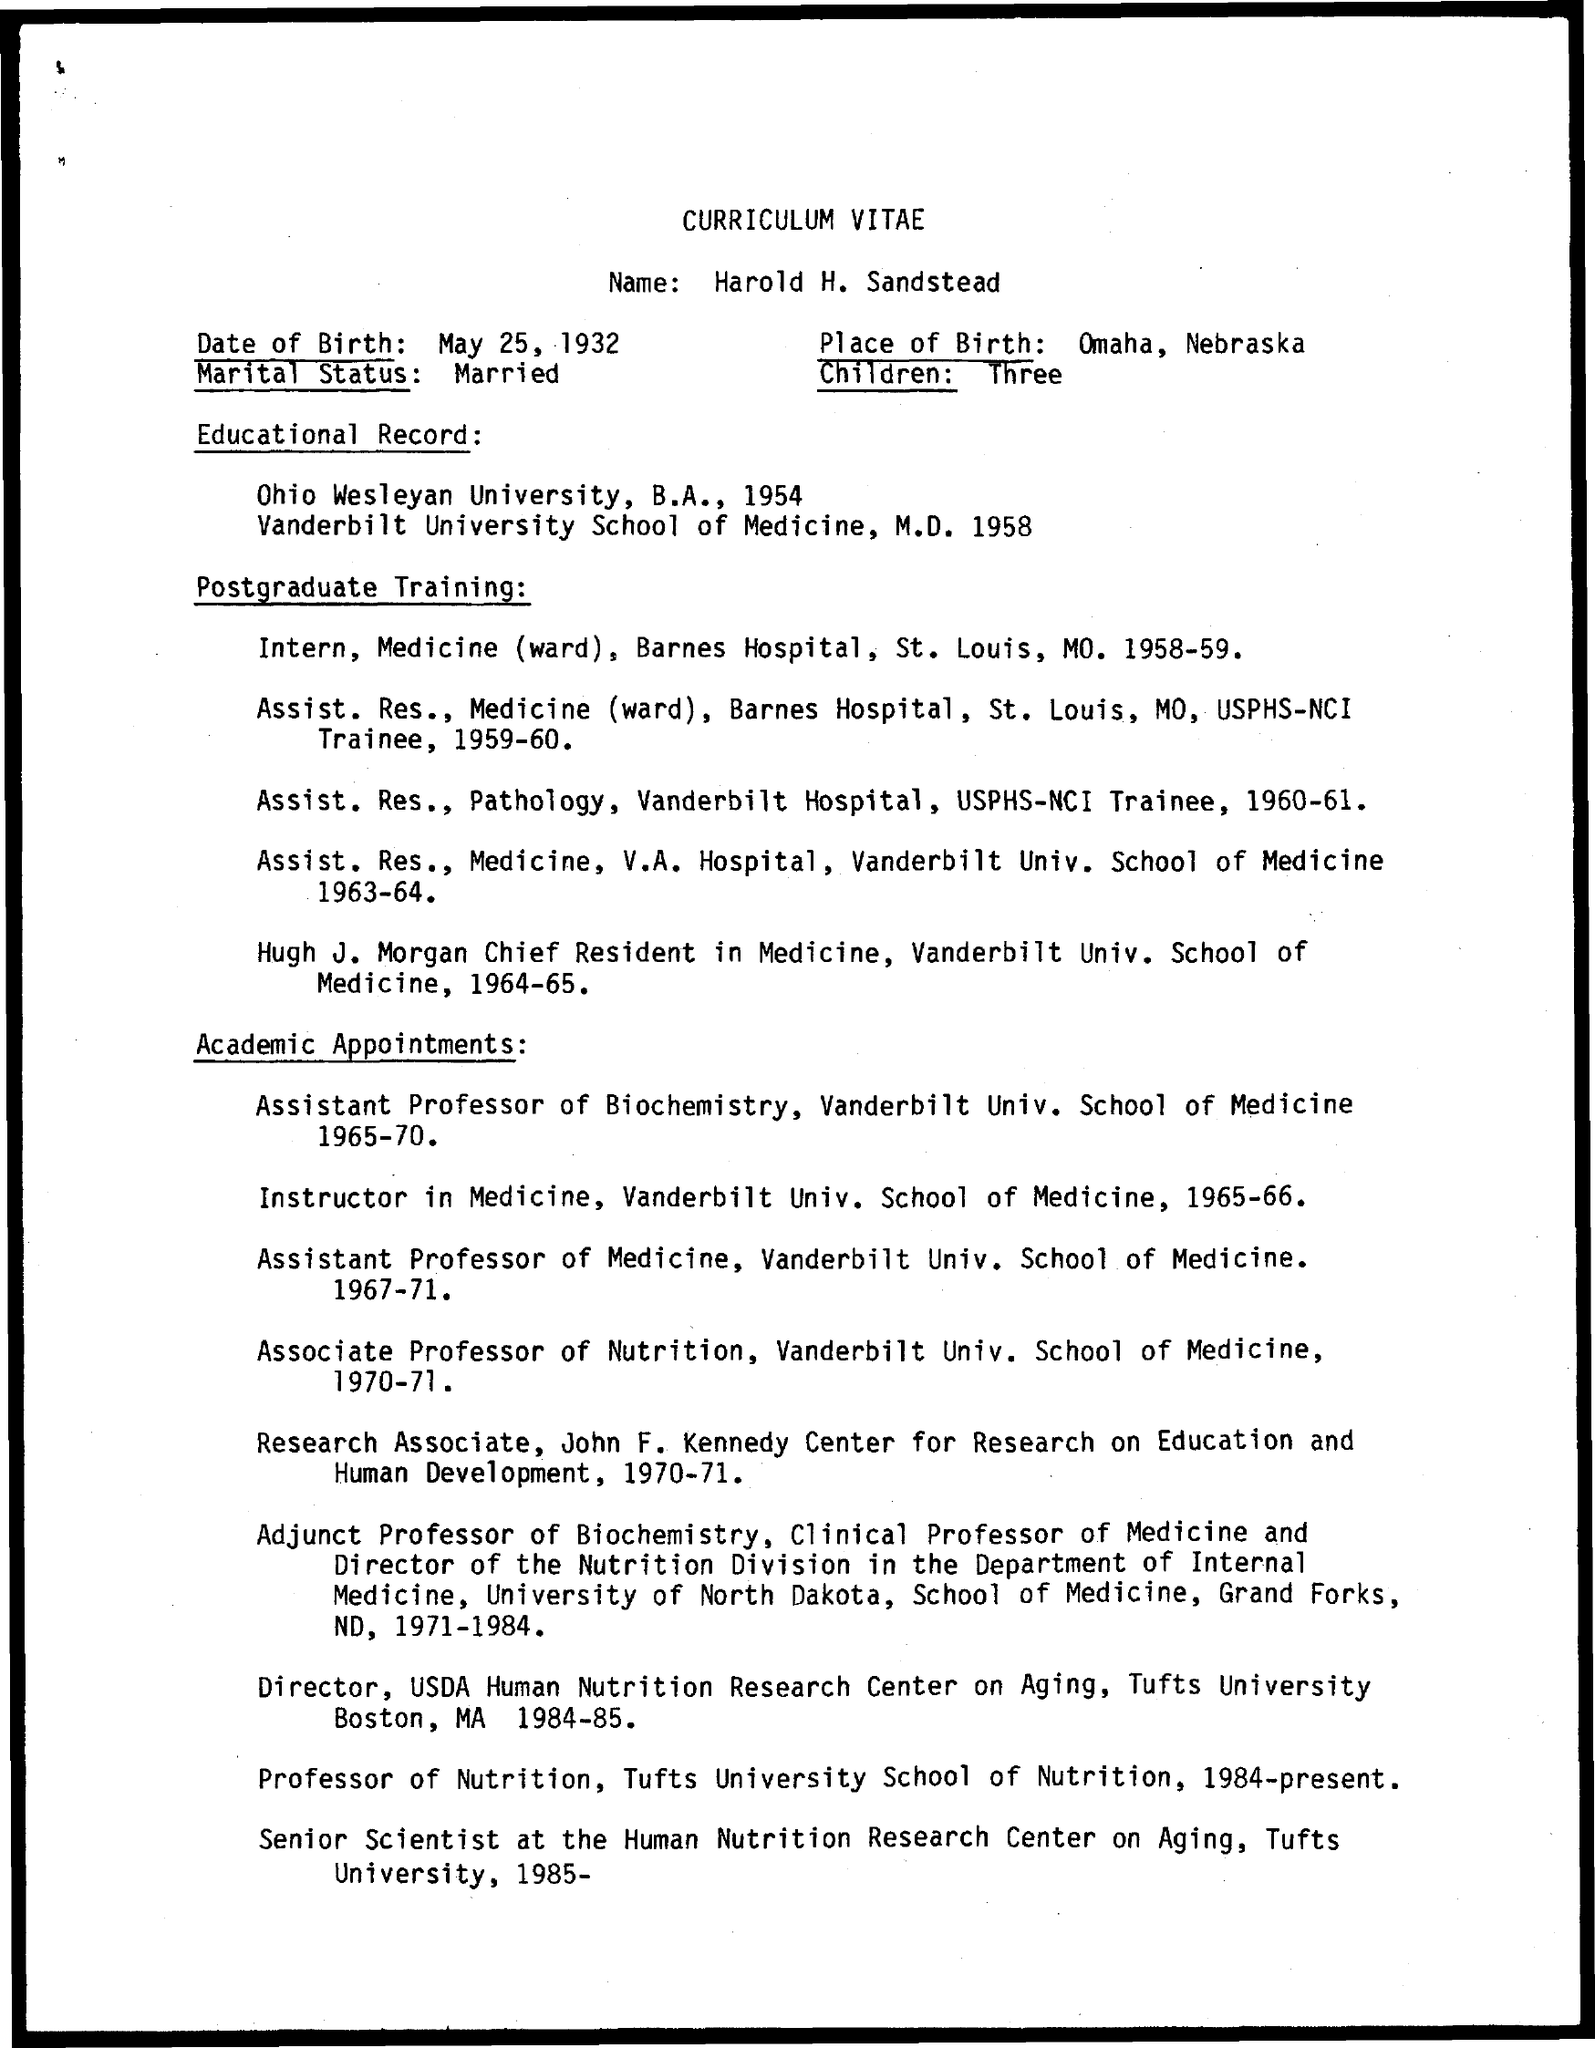To whom this curriculum vitae belongs to ?
Make the answer very short. Harold H. Sandstead. What is the place of birth mentioned in the given curriculum vitae ?
Ensure brevity in your answer.  Omaha, Nebraska. What is the marital status mentioned in the curriculum  vitae ?
Give a very brief answer. Married. What is the date of birth mentioned in the given curriculum vitae ?
Offer a very short reply. May 25, 1932. In which university sandstead completed his b.a as mentioned in the given curriculum vitae ?
Offer a very short reply. Ohio Wesleyan university. In which year sandstead completed his m.d in medicine as given in the curriculum vitae ?
Your answer should be compact. 1958. 